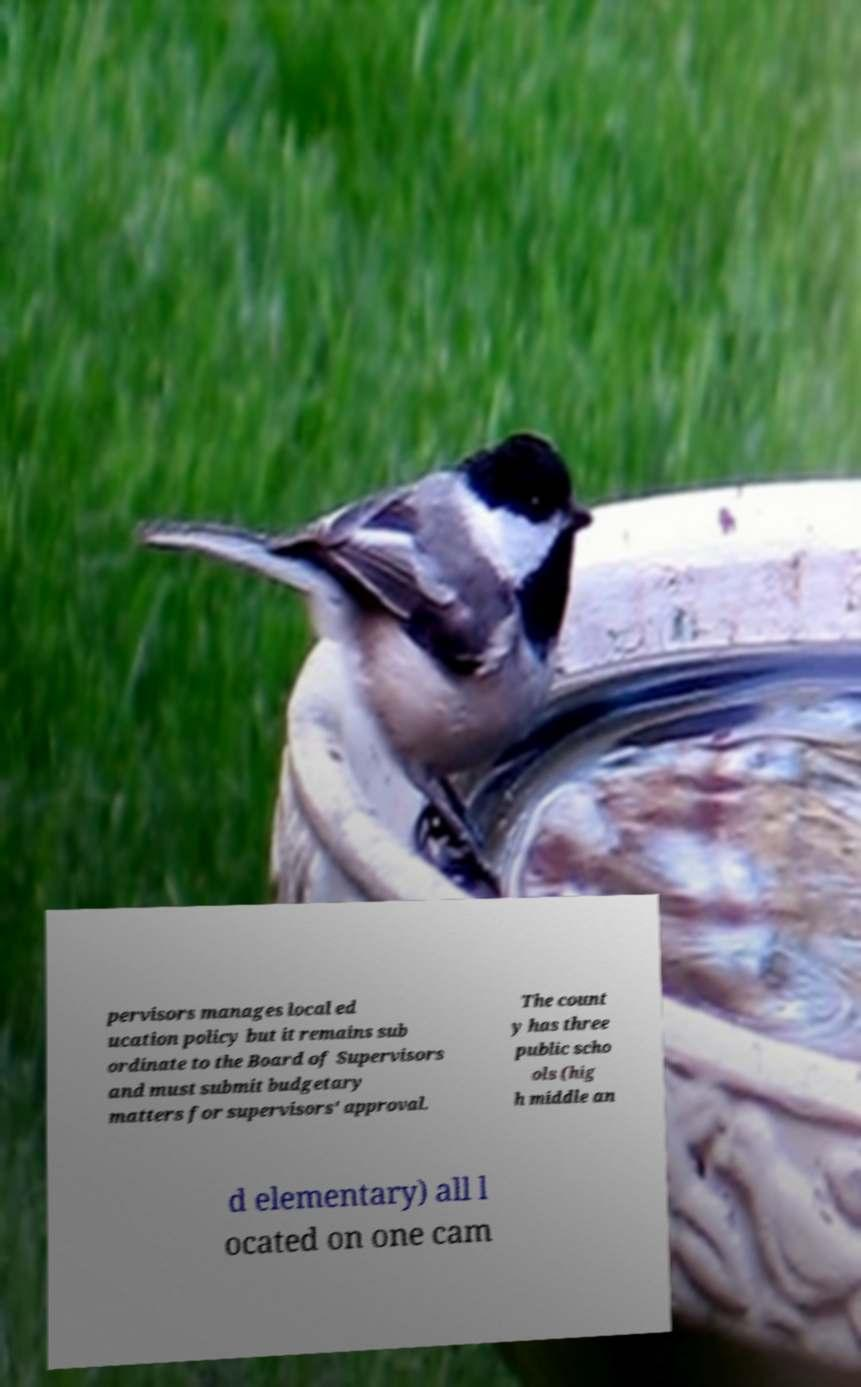There's text embedded in this image that I need extracted. Can you transcribe it verbatim? pervisors manages local ed ucation policy but it remains sub ordinate to the Board of Supervisors and must submit budgetary matters for supervisors' approval. The count y has three public scho ols (hig h middle an d elementary) all l ocated on one cam 